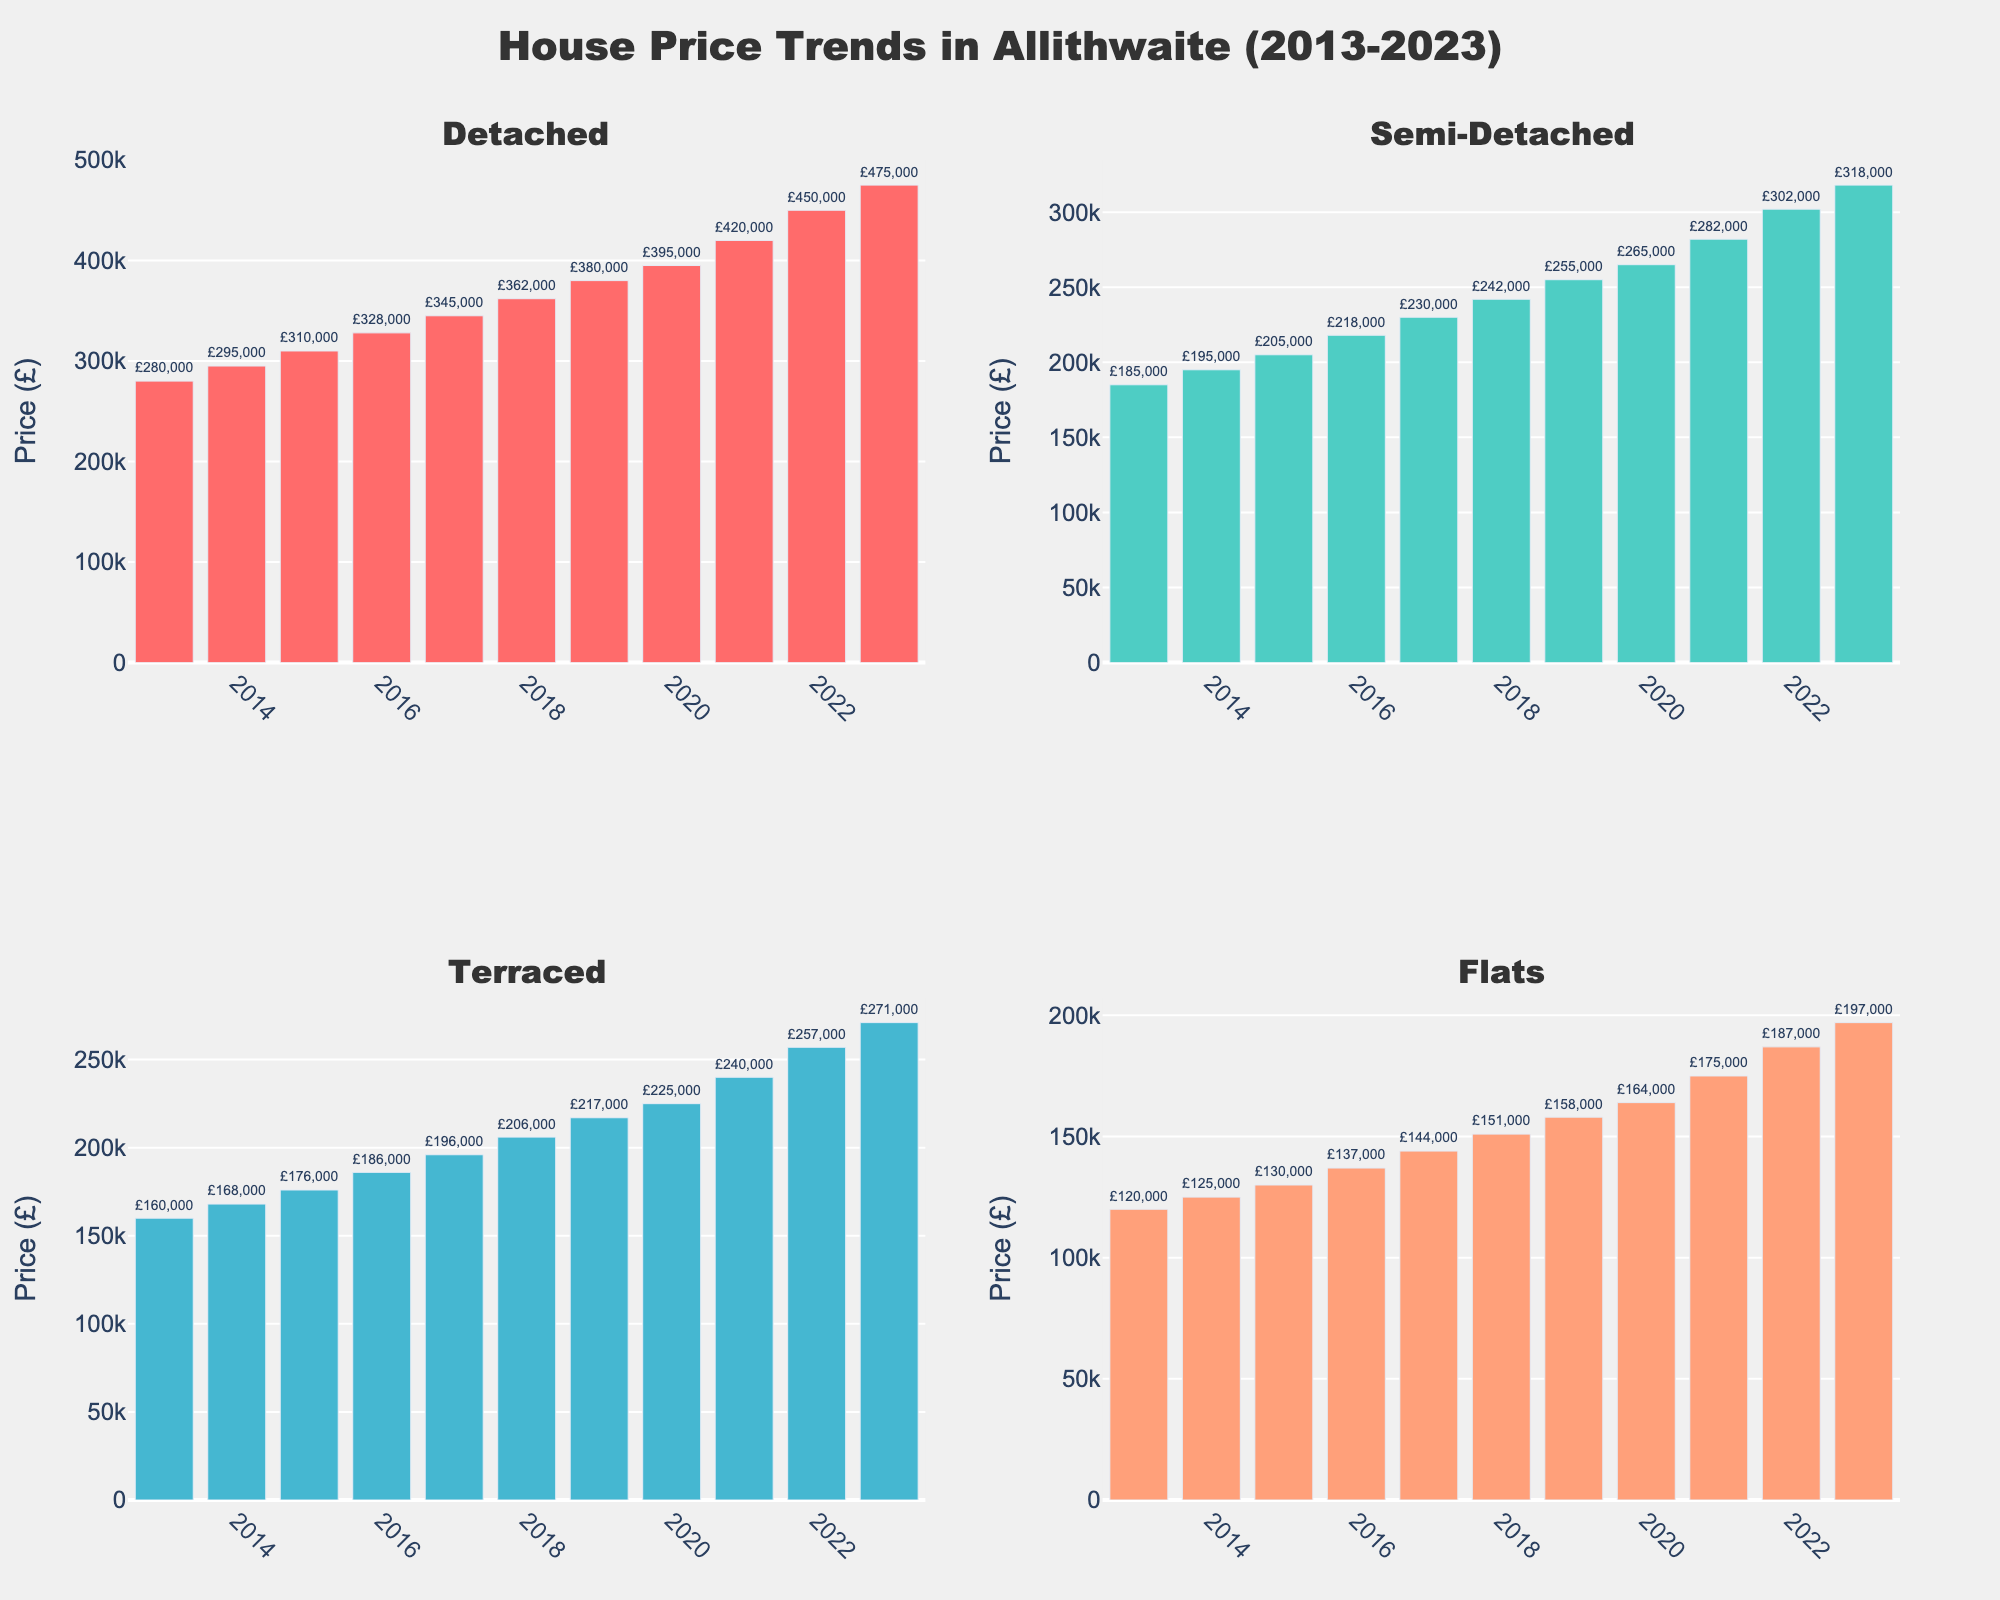What was the increase in the price of detached houses from 2013 to 2023? To find the increase, subtract the 2013 price from the 2023 price. The 2023 price for detached houses is £475,000 and the 2013 price is £280,000. So, the increase is £475,000 - £280,000 = £195,000.
Answer: £195,000 Which property type saw the highest price increase over the decade? Comparing the price increases from 2013 to 2023 for each property type, we have: Detached: £475,000 - £280,000 = £195,000, Semi-Detached: £318,000 - £185,000 = £133,000, Terraced: £271,000 - £160,000 = £111,000, Flats: £197,000 - £120,000 = £77,000. Detached properties saw the highest increase.
Answer: Detached In what year did semi-detached houses first exceed £200,000? Looking at the semi-detached houses prices, they first exceeded £200,000 in 2015 where the price was £205,000.
Answer: 2015 By how much did the price of flats change between 2015 and 2020? The price of flats in 2015 was £130,000 and in 2020 was £164,000. The change is £164,000 - £130,000 = £34,000.
Answer: £34,000 Which year saw the smallest increase in terraced houses' prices compared to the previous year? Comparing yearly increases for terraced houses: 
2014: +£8,000, 
2015: +£8,000, 
2016: +£10,000, 
2017: +£10,000, 
2018: +£10,000, 
2019: +£11,000, 
2020: +£8,000, 
2021: +£15,000, 
2022: +£17,000, 
2023: +£14,000. 
The smallest increase occurred between 2014 and 2015 with just £8,000.
Answer: 2014 to 2015 How does the price increase of terraced houses in 2022 compare to the price increase of flats in the same year? The price increase for terraced houses from 2021 to 2022 is £257,000 - £240,000 = £17,000. For flats, the increase is £187,000 - £175,000 = £12,000. By comparison, terraced houses increased more than flats in 2022 by £17,000 - £12,000 = £5,000.
Answer: Terraced houses increased by £5,000 more than flats What is the average annual price for detached houses over the decade? Sum the prices of detached houses from 2013 to 2023 and divide by the number of years. Sum = £280,000 + £295,000 + £310,000 + £328,000 + £345,000 + £362,000 + £380,000 + £395,000 + £420,000 + £450,000 + £475,000 = £4,040,000. Average = £4,040,000 / 11 ≈ £367,273.
Answer: £367,273 Which property type saw the least growth in absolute terms over the entire period? Calculating the total growth from 2013 to 2023 for each property type: Detached: £195,000, Semi-Detached: £133,000, Terraced: £111,000, Flats: £77,000. Flats had the least growth in absolute terms.
Answer: Flats 